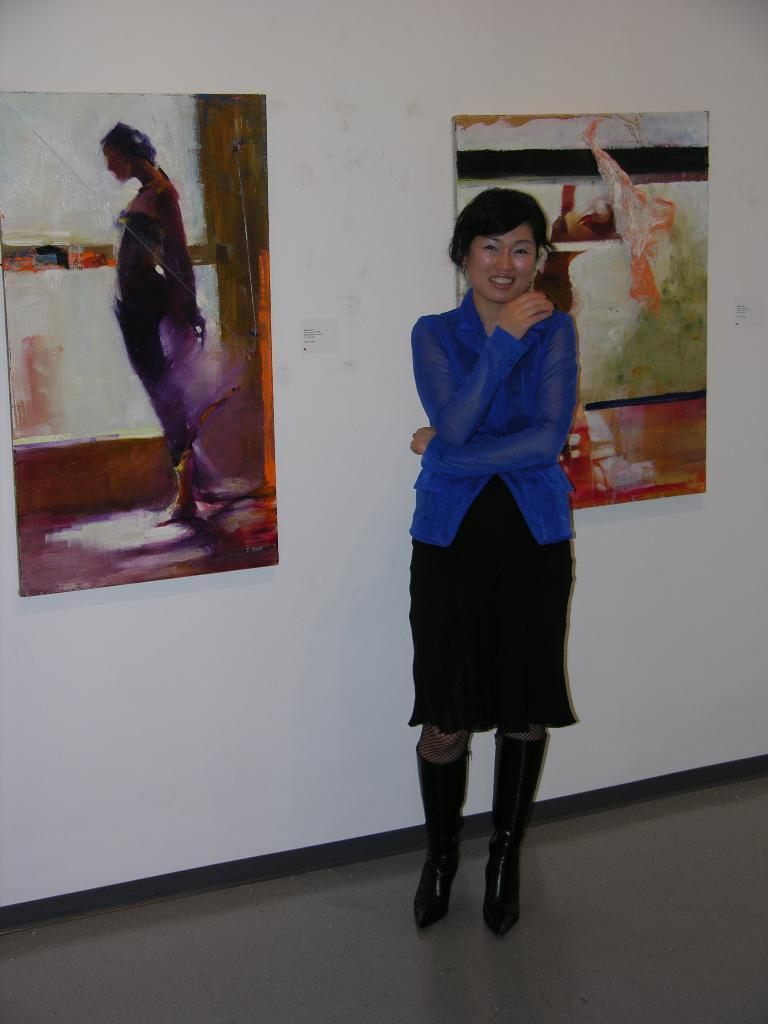What is the main subject in the foreground of the image? There is a lady standing in the foreground of the image. What can be seen in the background of the image? There are paintings in the background of the image. How many dogs are visible in the image? There are no dogs present in the image. What type of sign can be seen hanging on the wall in the image? There is no sign visible in the image; it only features a lady and paintings in the background. 